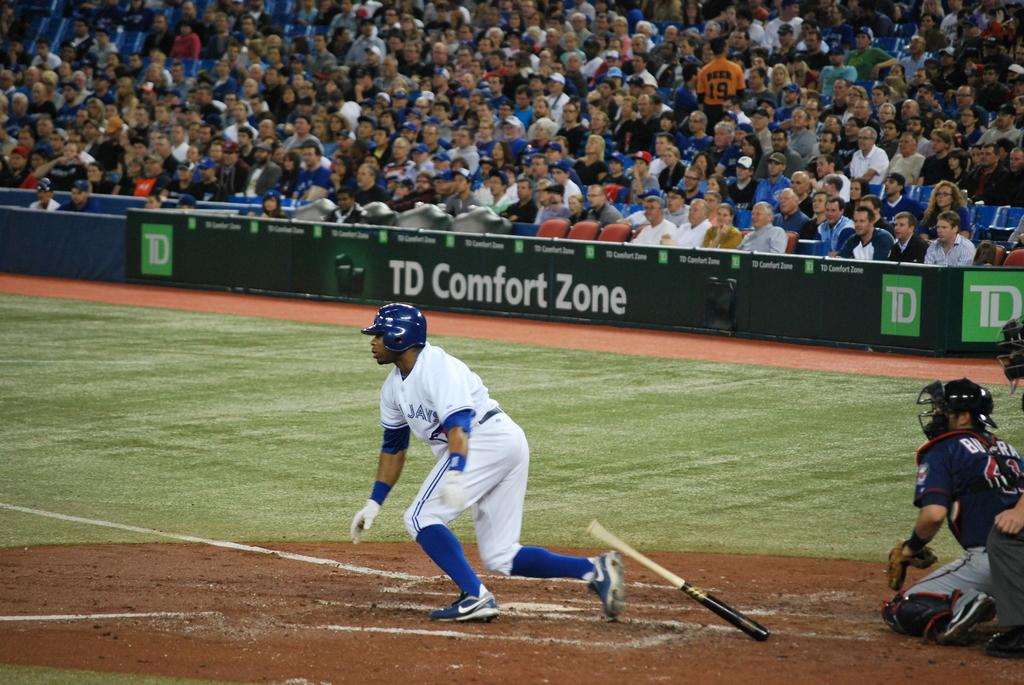What kind of zone is it?
Your answer should be very brief. Td comfort zone. What team does the batter play for?
Make the answer very short. Jays. 